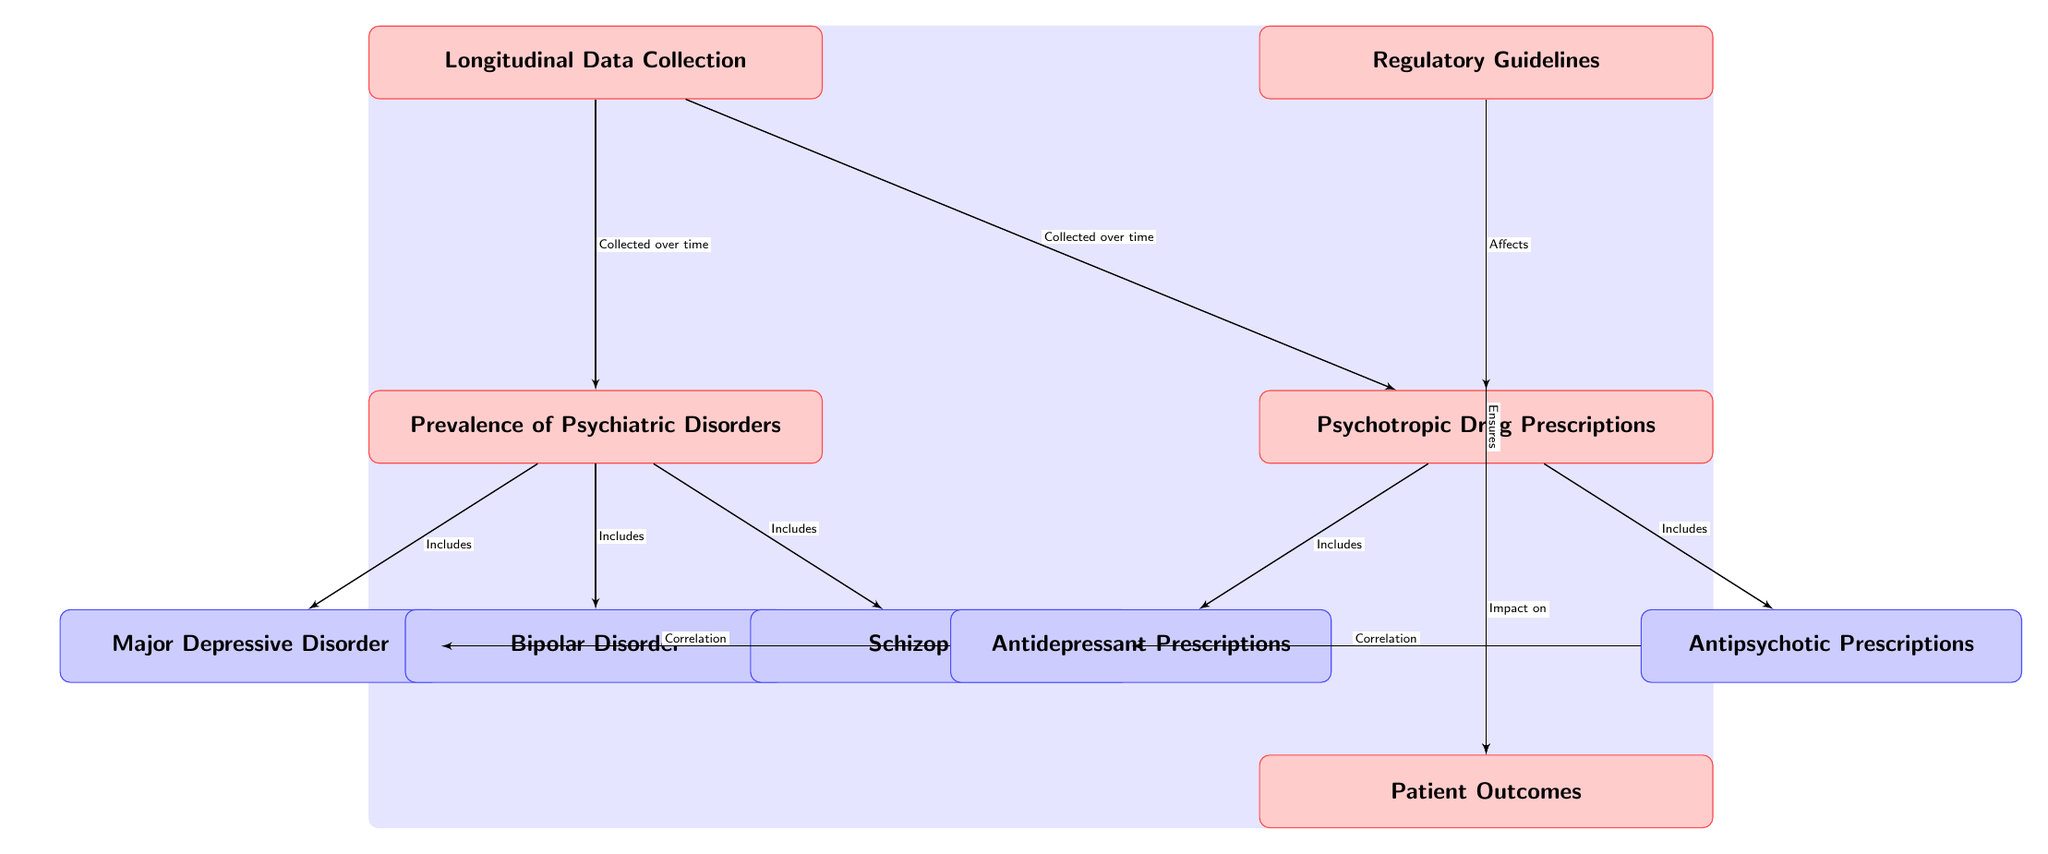What is the main focus of the diagram? The diagram primarily illustrates the relationship between the prevalence of psychiatric disorders and psychotropic drug prescriptions, along with longitudinal data collection and regulatory guidelines.
Answer: Psychiatric disorders and drug prescriptions How many types of psychiatric disorders are included in the diagram? The diagram includes three specific types of psychiatric disorders: Major Depressive Disorder, Bipolar Disorder, and Schizophrenia.
Answer: Three Which type of drug is correlated with Major Depressive Disorder? The diagram indicates that antidepressant prescriptions are correlated with Major Depressive Disorder as shown by the edge connecting them with a "Correlation" label.
Answer: Antidepressant Prescriptions What do regulatory guidelines affect according to the diagram? Per the diagram, regulatory guidelines affect psychotropic drug prescriptions and ensure patient outcomes, as indicated by the outgoing edges from the regulatory node.
Answer: Psychotropic drug prescriptions and outcomes What is the relationship between prescriptions and patient outcomes? The diagram shows that psychotropic drug prescriptions have an impact on patient outcomes, as indicated by the direct edge with an "Impact on" label connecting prescriptions to outcomes.
Answer: Impact How is data collection characterized in the diagram? The diagram highlights that the longitudinal data collection is carried out over time for both the prevalence of psychiatric disorders and drug prescriptions, as shown by the edges originating from the longitudinal node.
Answer: Collected over time What is the effect of regulatory guidelines on outcomes? Regulatory guidelines ensure patient outcomes, as depicted by the sloped edge connecting the regulatory node to outcomes with an "Ensures" label.
Answer: Ensures What is the minimum number of nodes displayed in the diagram? The diagram consists of a total of five main nodes plus the three sub-nodes of specific psychiatric disorders and the two sub-nodes of prescriptions, leading to a minimum total of ten distinct nodes.
Answer: Ten Which disorder is associated with antipsychotic prescriptions? The diagram illustrates that antipsychotic prescriptions are correlated with schizophrenia, as indicated by the edge with a "Correlation" label connecting them.
Answer: Schizophrenia 